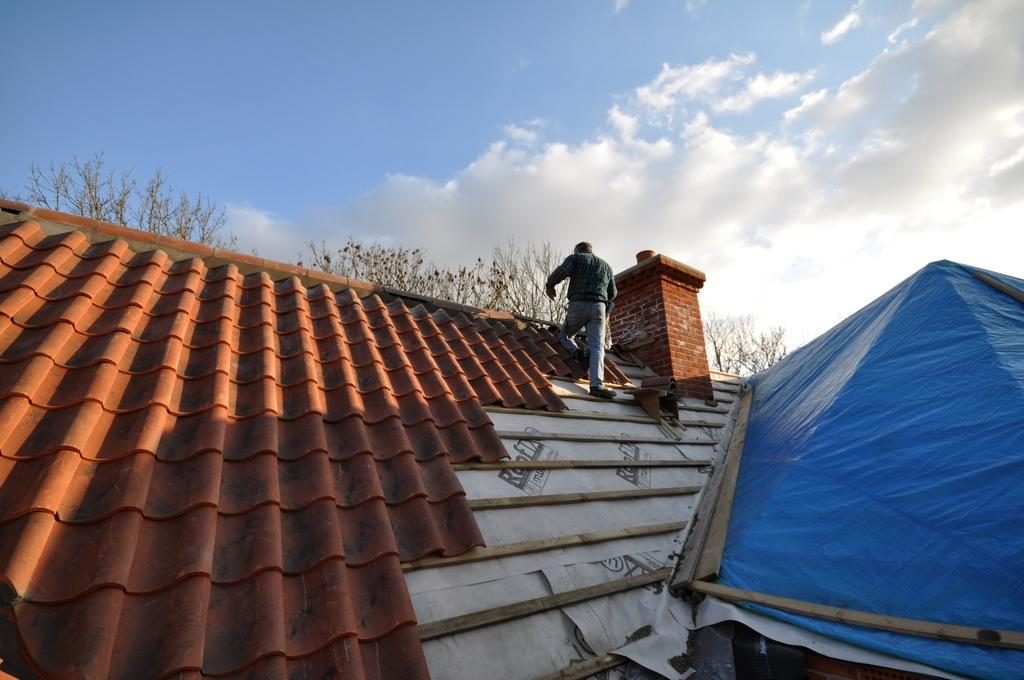Who is the main subject in the image? There is a man in the image. What is the man doing in the image? The man is trying to cover the roof of a house. What color is the cover that is visible in the image? There is a blue color cover on the right side of the image. What type of vegetation can be seen in the image? There are trees in the middle of the image. What is the man's belief about the governor in the image? There is no mention of a governor or any beliefs in the image; it only shows a man trying to cover the roof of a house. 